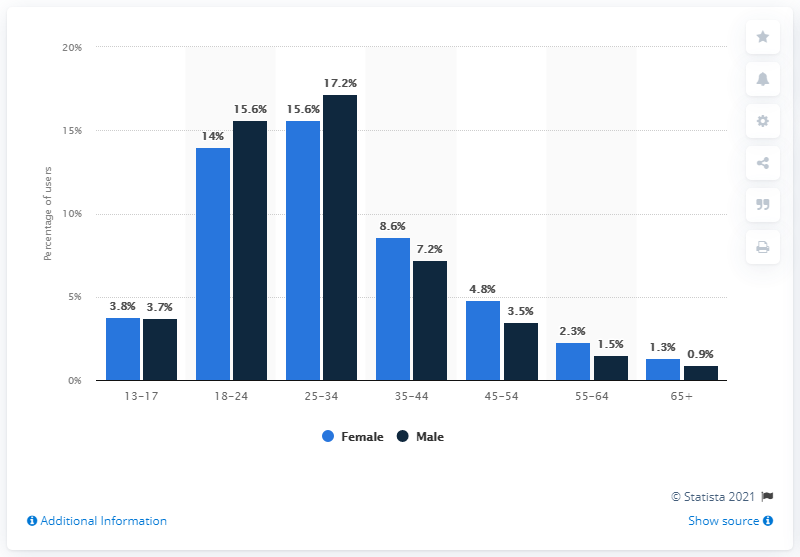List a handful of essential elements in this visual. According to statistics, 15.6% of Instagram users fell into the demographic of women between the ages of 25 and 34. 